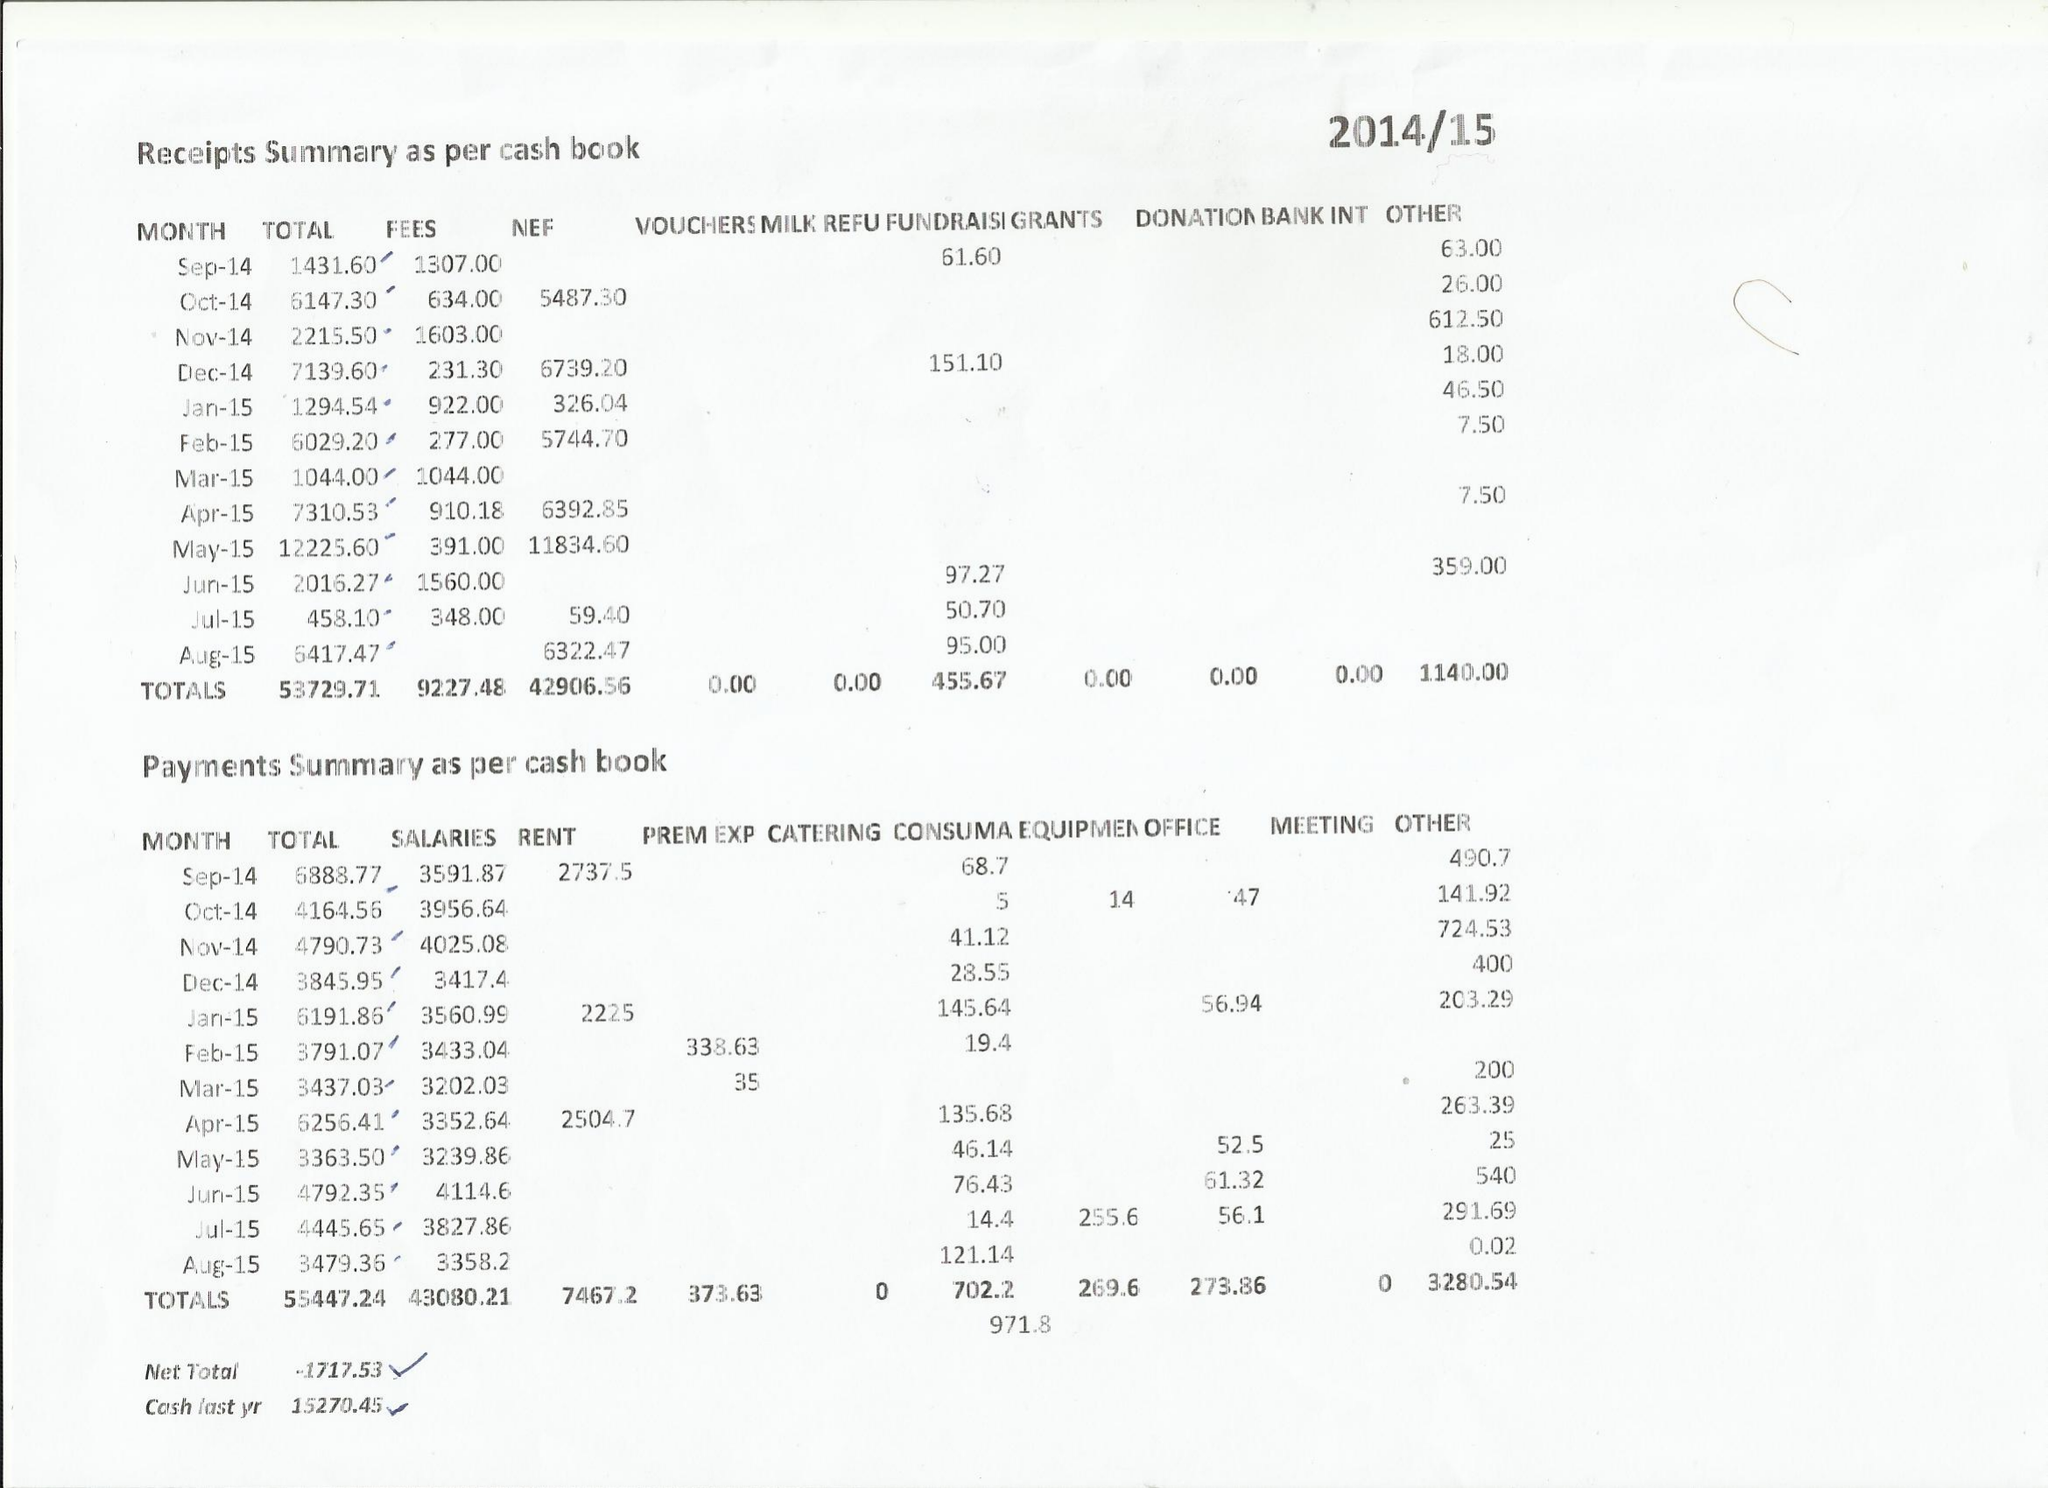What is the value for the spending_annually_in_british_pounds?
Answer the question using a single word or phrase. 55447.00 